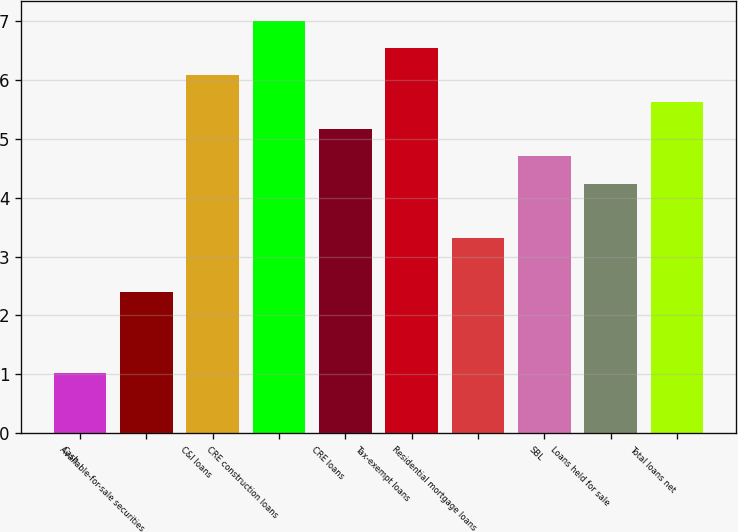Convert chart. <chart><loc_0><loc_0><loc_500><loc_500><bar_chart><fcel>Cash<fcel>Available-for-sale securities<fcel>C&I loans<fcel>CRE construction loans<fcel>CRE loans<fcel>Tax-exempt loans<fcel>Residential mortgage loans<fcel>SBL<fcel>Loans held for sale<fcel>Total loans net<nl><fcel>1.02<fcel>2.4<fcel>6.08<fcel>7<fcel>5.16<fcel>6.54<fcel>3.32<fcel>4.7<fcel>4.24<fcel>5.62<nl></chart> 